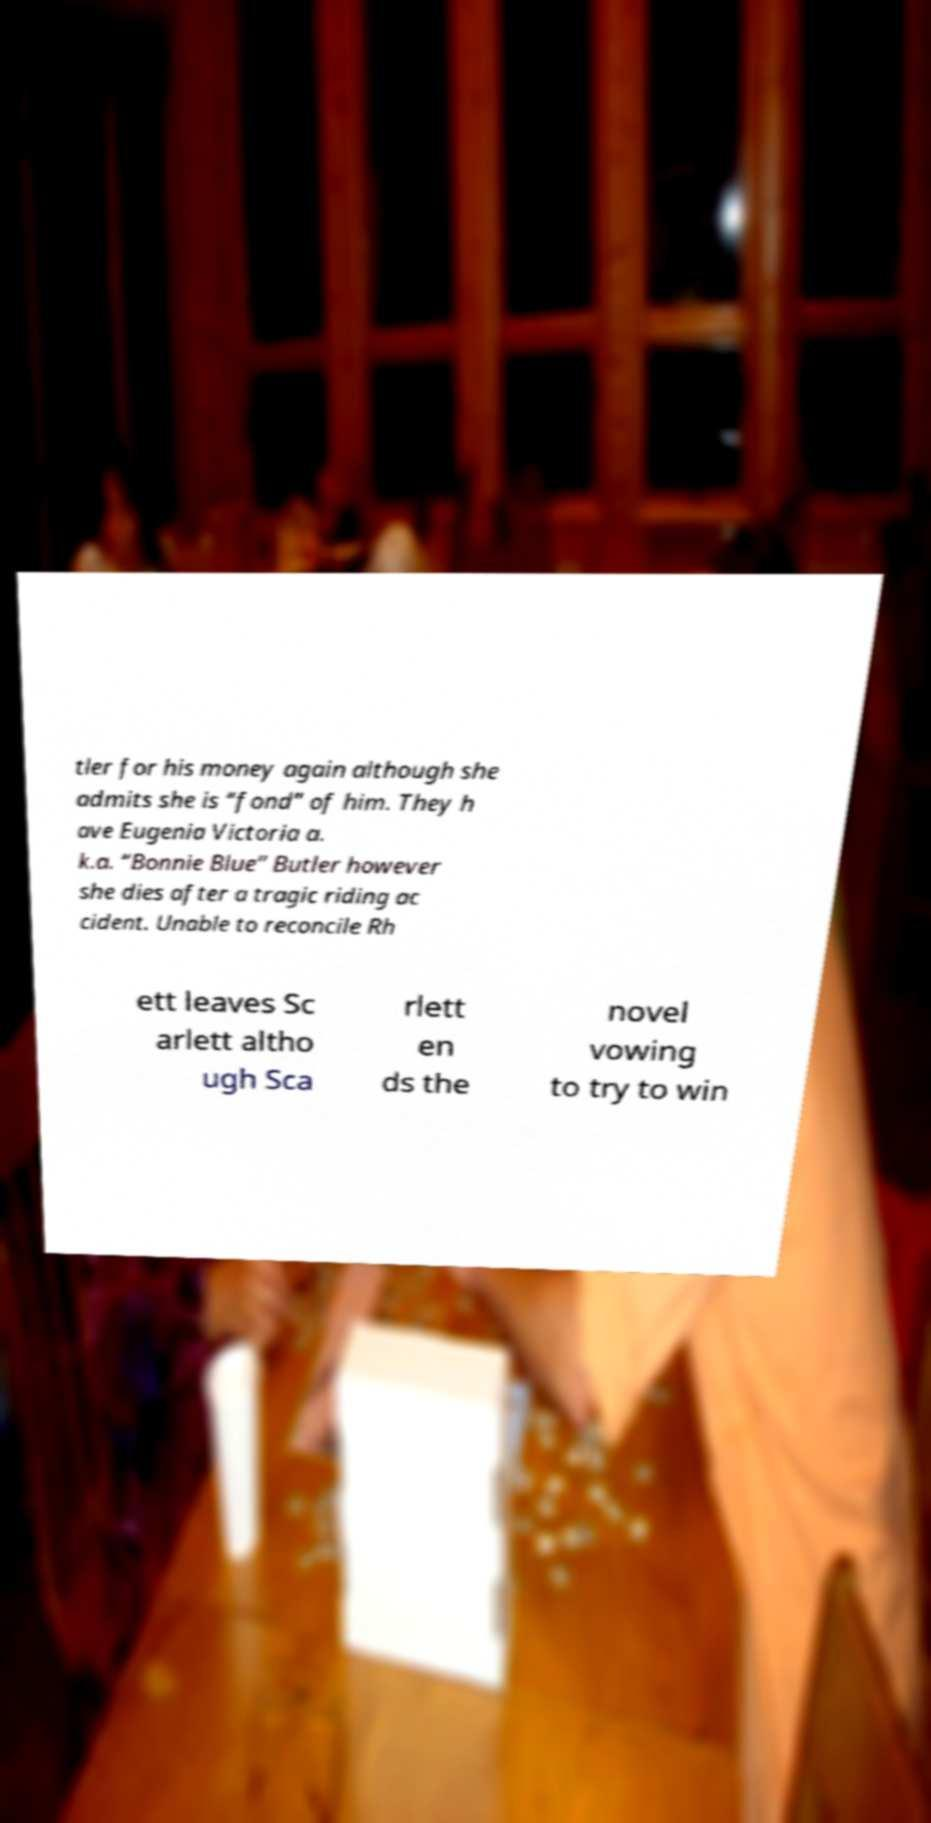There's text embedded in this image that I need extracted. Can you transcribe it verbatim? tler for his money again although she admits she is “fond” of him. They h ave Eugenia Victoria a. k.a. “Bonnie Blue” Butler however she dies after a tragic riding ac cident. Unable to reconcile Rh ett leaves Sc arlett altho ugh Sca rlett en ds the novel vowing to try to win 